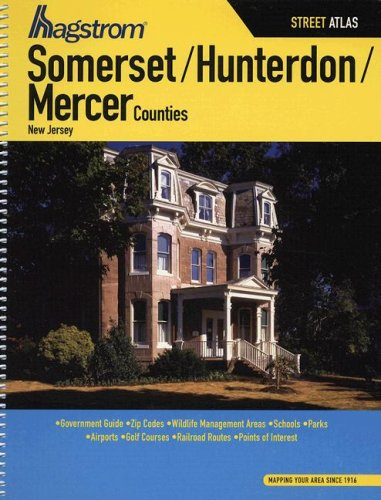What is the title of this book?
Answer the question using a single word or phrase. Hagstrom Somerset/Hunterdon/Mercer Counties, New Jersey Street Atlas (Hagstrom Somerset/Hunterdon/Mercer County Atlas) What type of book is this? Travel Is this a journey related book? Yes 